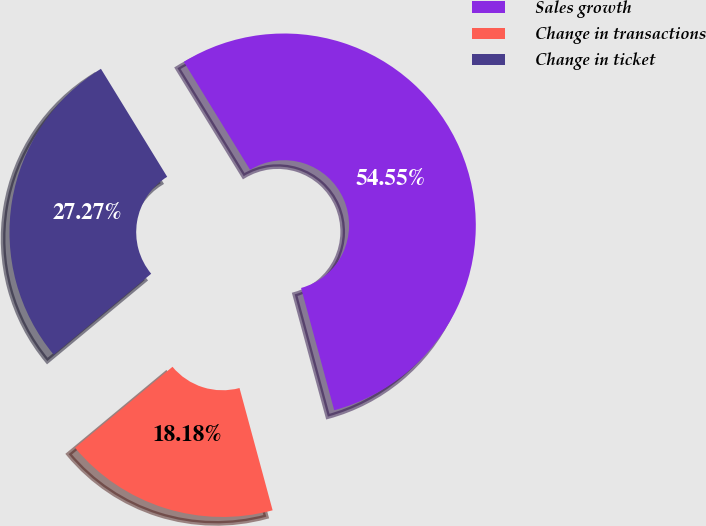Convert chart. <chart><loc_0><loc_0><loc_500><loc_500><pie_chart><fcel>Sales growth<fcel>Change in transactions<fcel>Change in ticket<nl><fcel>54.55%<fcel>18.18%<fcel>27.27%<nl></chart> 